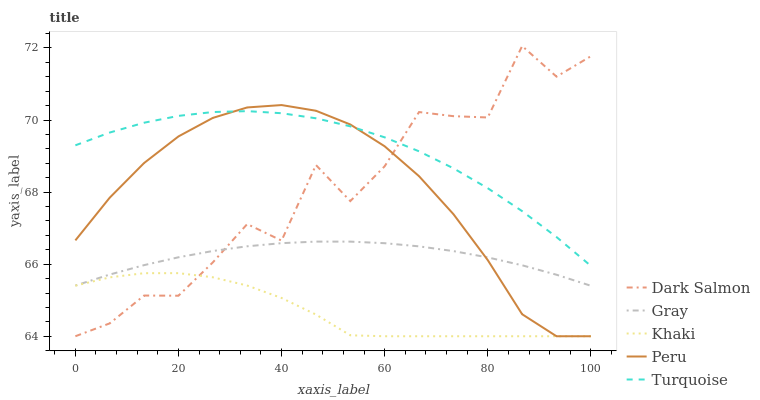Does Khaki have the minimum area under the curve?
Answer yes or no. Yes. Does Turquoise have the maximum area under the curve?
Answer yes or no. Yes. Does Turquoise have the minimum area under the curve?
Answer yes or no. No. Does Khaki have the maximum area under the curve?
Answer yes or no. No. Is Gray the smoothest?
Answer yes or no. Yes. Is Dark Salmon the roughest?
Answer yes or no. Yes. Is Turquoise the smoothest?
Answer yes or no. No. Is Turquoise the roughest?
Answer yes or no. No. Does Khaki have the lowest value?
Answer yes or no. Yes. Does Turquoise have the lowest value?
Answer yes or no. No. Does Dark Salmon have the highest value?
Answer yes or no. Yes. Does Turquoise have the highest value?
Answer yes or no. No. Is Gray less than Turquoise?
Answer yes or no. Yes. Is Turquoise greater than Khaki?
Answer yes or no. Yes. Does Dark Salmon intersect Peru?
Answer yes or no. Yes. Is Dark Salmon less than Peru?
Answer yes or no. No. Is Dark Salmon greater than Peru?
Answer yes or no. No. Does Gray intersect Turquoise?
Answer yes or no. No. 